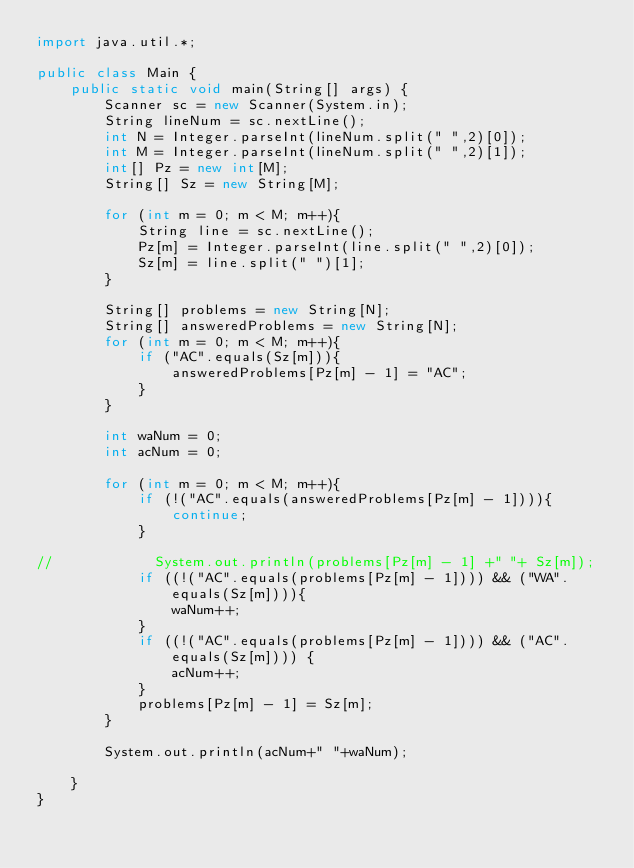Convert code to text. <code><loc_0><loc_0><loc_500><loc_500><_Java_>import java.util.*;

public class Main {
    public static void main(String[] args) {
        Scanner sc = new Scanner(System.in);
        String lineNum = sc.nextLine();
        int N = Integer.parseInt(lineNum.split(" ",2)[0]);
        int M = Integer.parseInt(lineNum.split(" ",2)[1]);
        int[] Pz = new int[M];
        String[] Sz = new String[M];

        for (int m = 0; m < M; m++){
            String line = sc.nextLine();
            Pz[m] = Integer.parseInt(line.split(" ",2)[0]);
            Sz[m] = line.split(" ")[1];
        }

        String[] problems = new String[N];
        String[] answeredProblems = new String[N];
        for (int m = 0; m < M; m++){
            if ("AC".equals(Sz[m])){
                answeredProblems[Pz[m] - 1] = "AC";
            }
        }

        int waNum = 0;
        int acNum = 0;

        for (int m = 0; m < M; m++){
            if (!("AC".equals(answeredProblems[Pz[m] - 1]))){
                continue;
            }

//            System.out.println(problems[Pz[m] - 1] +" "+ Sz[m]);
            if ((!("AC".equals(problems[Pz[m] - 1]))) && ("WA".equals(Sz[m]))){
                waNum++;
            }
            if ((!("AC".equals(problems[Pz[m] - 1]))) && ("AC".equals(Sz[m]))) {
                acNum++;
            }
            problems[Pz[m] - 1] = Sz[m];
        }

        System.out.println(acNum+" "+waNum);

    }
}

</code> 